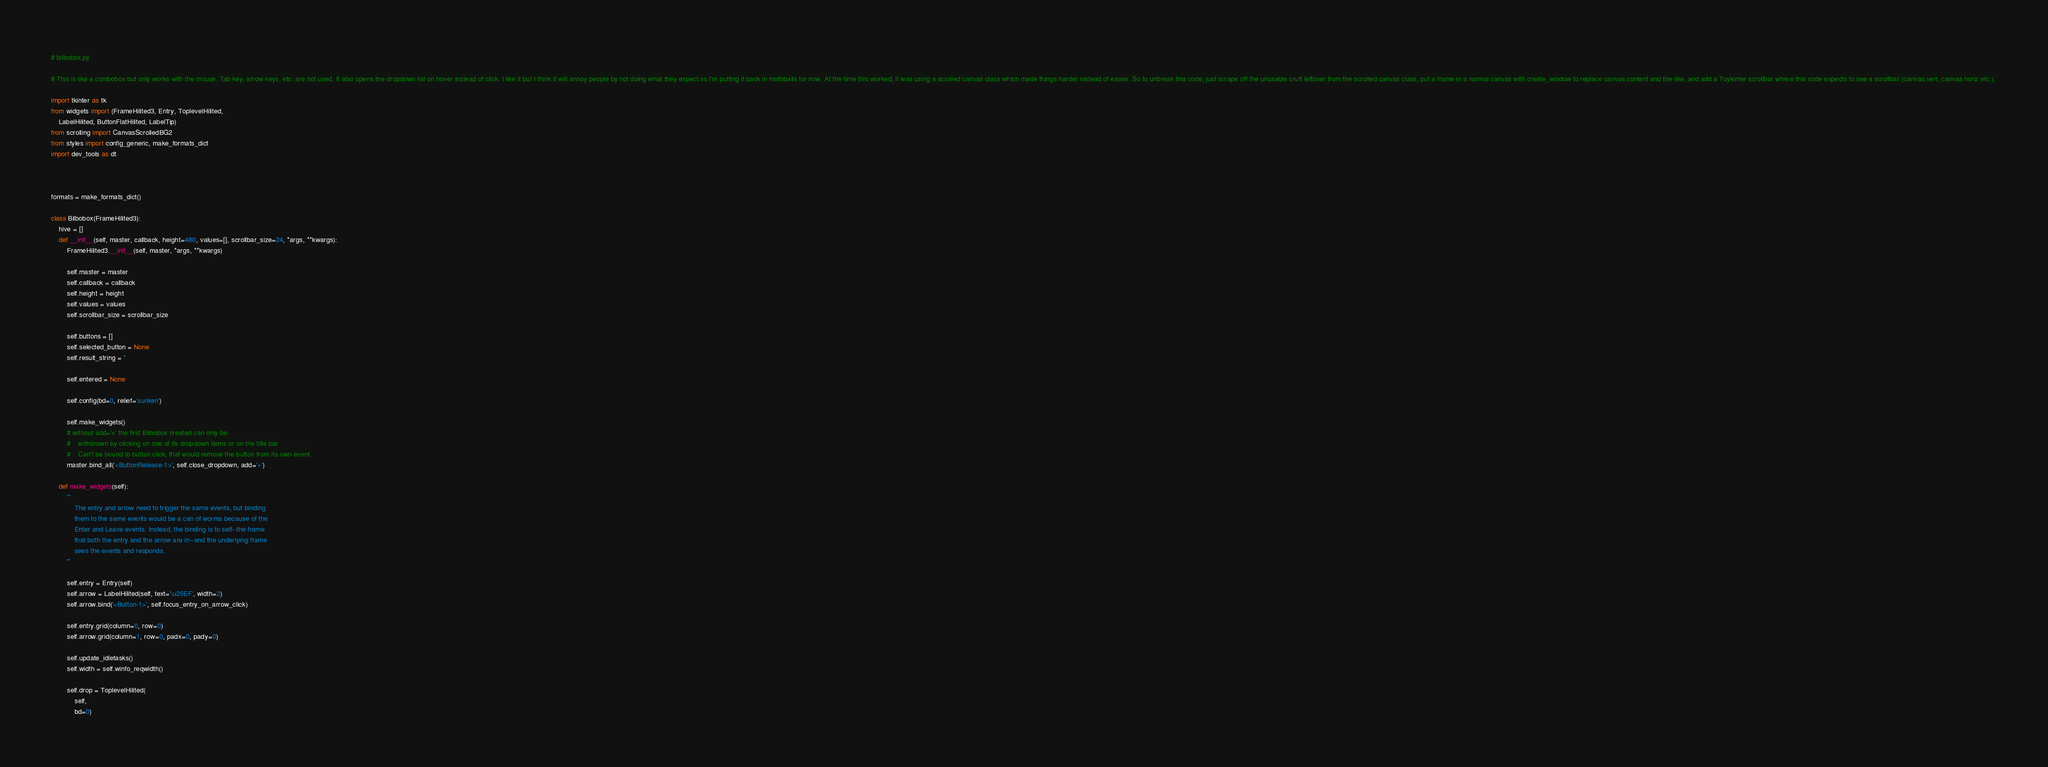<code> <loc_0><loc_0><loc_500><loc_500><_Python_># bilbobox.py

# This is like a combobox but only works with the mouse. Tab key, arrow keys, etc. are not used. It also opens the dropdown list on hover instead of click. I like it but I think it will annoy people by not doing what they expect so I'm putting it back in mothballs for now. At the time this worked, it was using a scrolled canvas class which made things harder instead of easier. So to unbreak this code, just scrape off the unusable cruft leftover from the scrolled canvas class, put a frame in a normal canvas with create_window to replace canvas.content and the like, and add a Toykinter scrollbar where this code expects to see a scrollbar (canvas.vert, canvas.horiz etc.). 

import tkinter as tk
from widgets import (FrameHilited3, Entry, ToplevelHilited, 
    LabelHilited, ButtonFlatHilited, LabelTip)
from scrolling import CanvasScrolledBG2
from styles import config_generic, make_formats_dict
import dev_tools as dt



formats = make_formats_dict()

class Bilbobox(FrameHilited3):
    hive = []
    def __init__(self, master, callback, height=480, values=[], scrollbar_size=24, *args, **kwargs):
        FrameHilited3.__init__(self, master, *args, **kwargs)

        self.master = master
        self.callback = callback
        self.height = height
        self.values = values
        self.scrollbar_size = scrollbar_size

        self.buttons = []
        self.selected_button = None
        self.result_string = ''

        self.entered = None

        self.config(bd=0, relief='sunken')

        self.make_widgets()
        # without add='+' the first Bilbobox created can only be 
        #    withdrawn by clicking on one of its dropdown items or on the title bar
        #    Can't be bound to button click; that would remove the button from its own event.
        master.bind_all('<ButtonRelease-1>', self.close_dropdown, add='+')
 
    def make_widgets(self):
        '''
            The entry and arrow need to trigger the same events, but binding
            them to the same events would be a can of worms because of the
            Enter and Leave events. Instead, the binding is to self--the frame 
            that both the entry and the arrow are in--and the underlying frame
            sees the events and responds.
        '''

        self.entry = Entry(self)
        self.arrow = LabelHilited(self, text='\u25EF', width=2)
        self.arrow.bind('<Button-1>', self.focus_entry_on_arrow_click)

        self.entry.grid(column=0, row=0)
        self.arrow.grid(column=1, row=0, padx=0, pady=0)

        self.update_idletasks()
        self.width = self.winfo_reqwidth()

        self.drop = ToplevelHilited(
            self,
            bd=0)</code> 